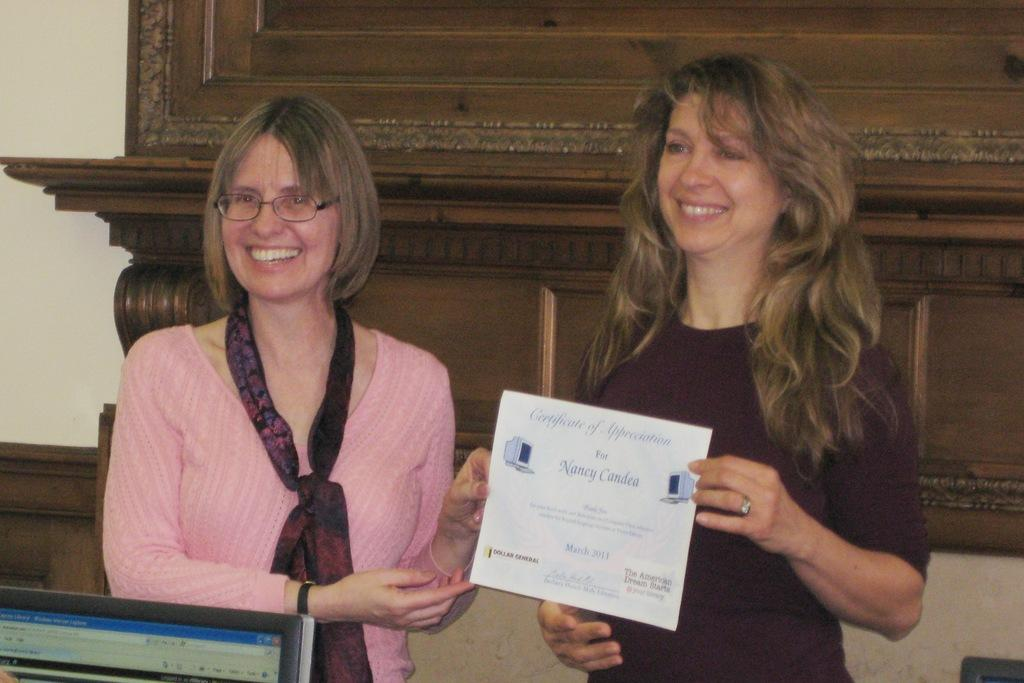<image>
Give a short and clear explanation of the subsequent image. One woman handing another woman a certificate of appreciation. 